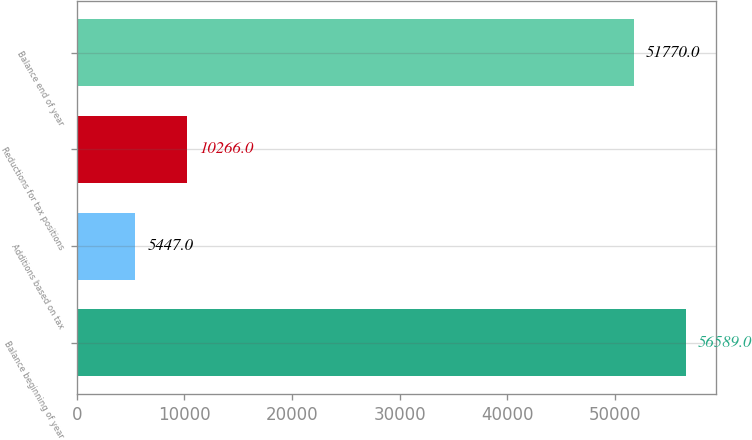Convert chart to OTSL. <chart><loc_0><loc_0><loc_500><loc_500><bar_chart><fcel>Balance beginning of year<fcel>Additions based on tax<fcel>Reductions for tax positions<fcel>Balance end of year<nl><fcel>56589<fcel>5447<fcel>10266<fcel>51770<nl></chart> 